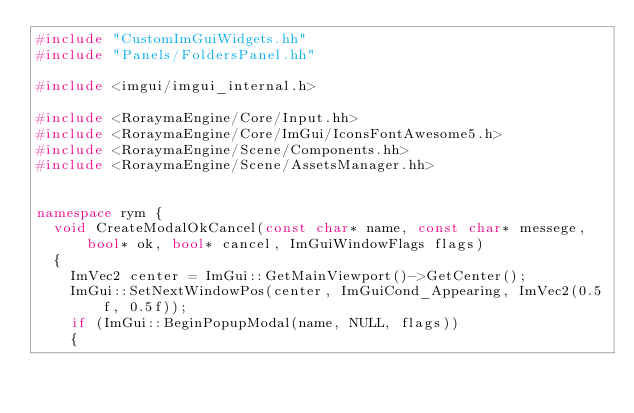<code> <loc_0><loc_0><loc_500><loc_500><_C++_>#include "CustomImGuiWidgets.hh"
#include "Panels/FoldersPanel.hh"

#include <imgui/imgui_internal.h>

#include <RoraymaEngine/Core/Input.hh>
#include <RoraymaEngine/Core/ImGui/IconsFontAwesome5.h>
#include <RoraymaEngine/Scene/Components.hh>
#include <RoraymaEngine/Scene/AssetsManager.hh>


namespace rym {
	void CreateModalOkCancel(const char* name, const char* messege, bool* ok, bool* cancel, ImGuiWindowFlags flags)
	{
		ImVec2 center = ImGui::GetMainViewport()->GetCenter();
		ImGui::SetNextWindowPos(center, ImGuiCond_Appearing, ImVec2(0.5f, 0.5f));
		if (ImGui::BeginPopupModal(name, NULL, flags))
		{</code> 